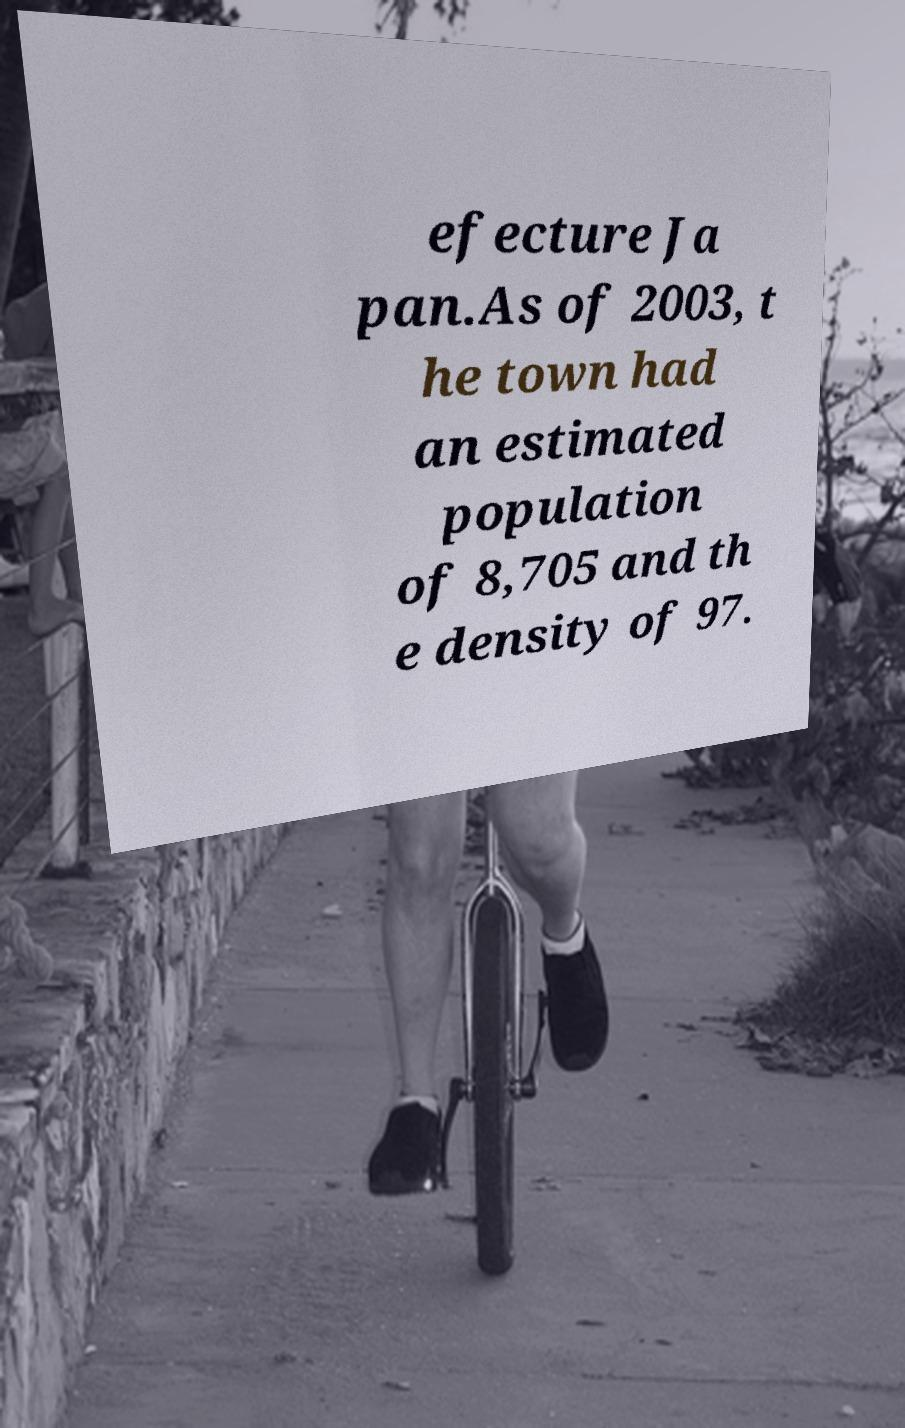For documentation purposes, I need the text within this image transcribed. Could you provide that? efecture Ja pan.As of 2003, t he town had an estimated population of 8,705 and th e density of 97. 